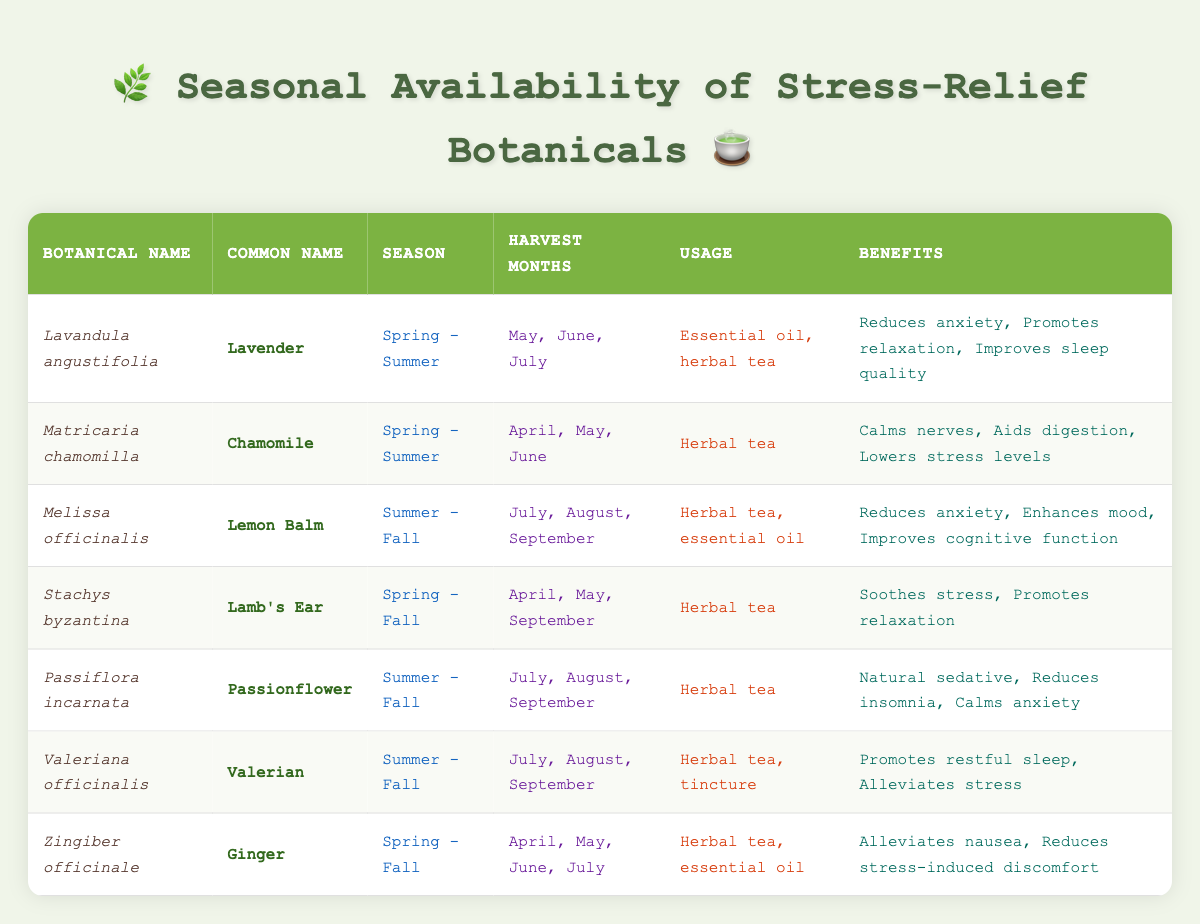What is the common name of Lavandula angustifolia? The botanical name Lavandula angustifolia corresponds to the common name Lavender, which is found in the table under the Common Name column.
Answer: Lavender Which botanicals are harvested in July? The botanicals harvested in July, as shown in the Harvest Months column are Lavender, Lemon Balm, Passionflower, Valerian, and Ginger. Each of these has July listed among their harvest months.
Answer: Lavender, Lemon Balm, Passionflower, Valerian, Ginger How many botanicals can be used as essential oils? The botanicals that can be used as essential oils are Lavender and Ginger. By referencing the Usage column, we see that these two have "essential oil" listed as part of their usage.
Answer: 2 Does Melissa officinalis have benefits related to anxiety? Yes, Melissa officinalis (Lemon Balm) has "Reduces anxiety" listed as one of its benefits in the Benefits column. This confirms its relation to alleviating anxiety.
Answer: Yes What is the average number of harvest months among the botanicals? To find the average number of harvest months, we count the harvest months for each botanical: Lavender (3), Chamomile (3), Lemon Balm (3), Lamb's Ear (3), Passionflower (3), Valerian (3), and Ginger (4). In total, that gives us 3 + 3 + 3 + 3 + 3 + 3 + 4 = 20. Since there are 7 botanicals, the average is 20/7 = approximately 2.86 (rounded to 3 months per botanical).
Answer: 3 Which botanical offers the highest number of benefits? By reviewing the Benefits column, we find that both Lavender and Chamomile list three benefits each, while others have two or three as well, but no botanical exceeds three. Thus, both Lavender and Chamomile offer the highest number of benefits at three each.
Answer: Lavender, Chamomile Is Ginger available for harvest in Spring? Yes, Ginger is available for harvest in Spring, with April, May, June, and July listed in the Harvest Months column indicating its availability during that season.
Answer: Yes How many botanicals are available in Spring? The botanicals available in Spring include Lavender, Chamomile, Lamb's Ear, and Ginger based on the Season column. Four botanicals are noted to be available in Spring.
Answer: 4 What common benefits do Valerian and Passionflower share? Both Valerian and Passionflower have "Alleviates stress" and "Promotes relaxation" as similar benefits. Valerian promotes restful sleep and Passionflower reduces insomnia, but both are focused on relaxation and stress relief.
Answer: Alleviates stress, Promotes relaxation 